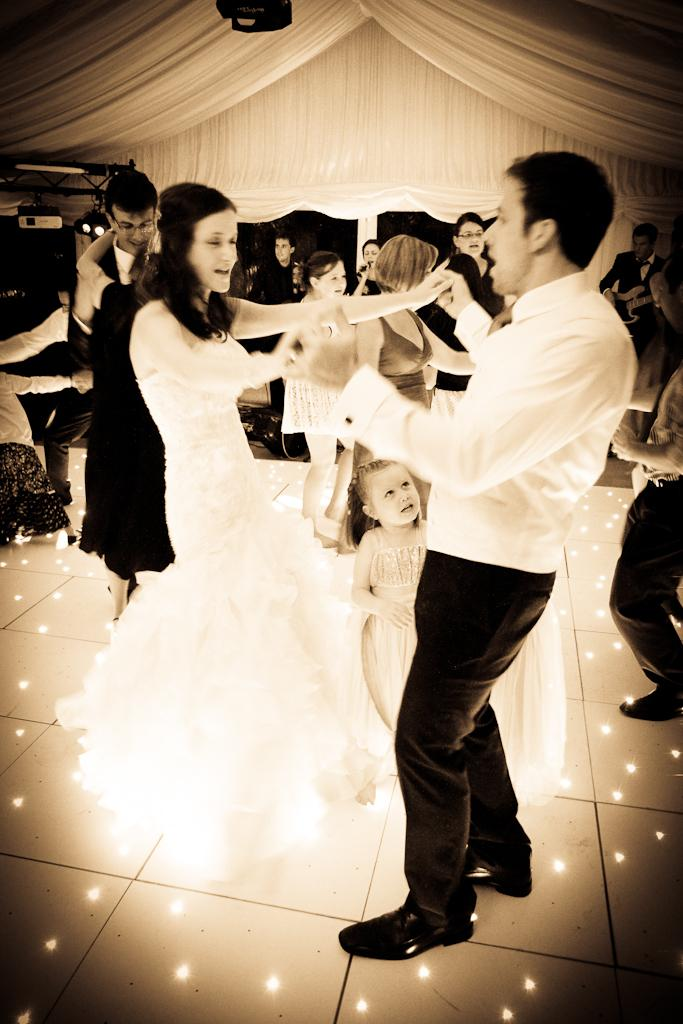How many people are in the image? There are multiple persons in the image. What are the persons doing in the image? The persons are dancing on the floor. Can you describe the surface on which the persons are dancing? There is a floor visible in the image. What can be seen in the background of the image? There is a white cloth in the background of the image. What type of print can be seen on the leather shoes of the persons in the image? There is no mention of shoes or prints in the provided facts, so we cannot determine the type of print on any leather shoes in the image. 